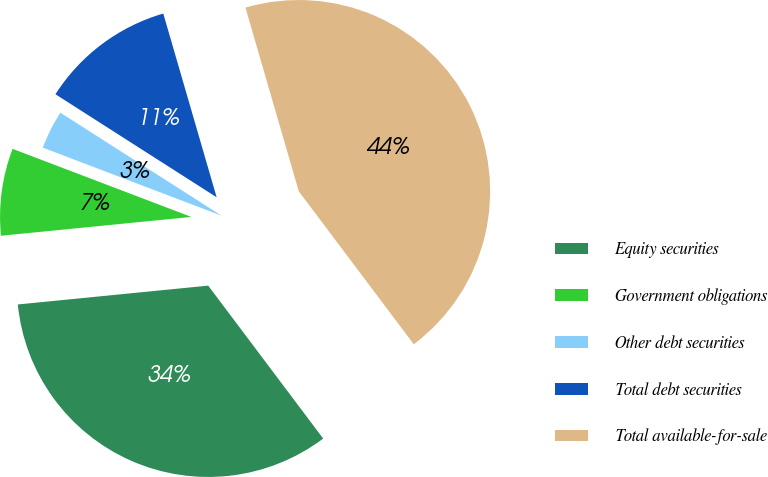Convert chart. <chart><loc_0><loc_0><loc_500><loc_500><pie_chart><fcel>Equity securities<fcel>Government obligations<fcel>Other debt securities<fcel>Total debt securities<fcel>Total available-for-sale<nl><fcel>33.69%<fcel>7.36%<fcel>3.26%<fcel>11.45%<fcel>44.24%<nl></chart> 